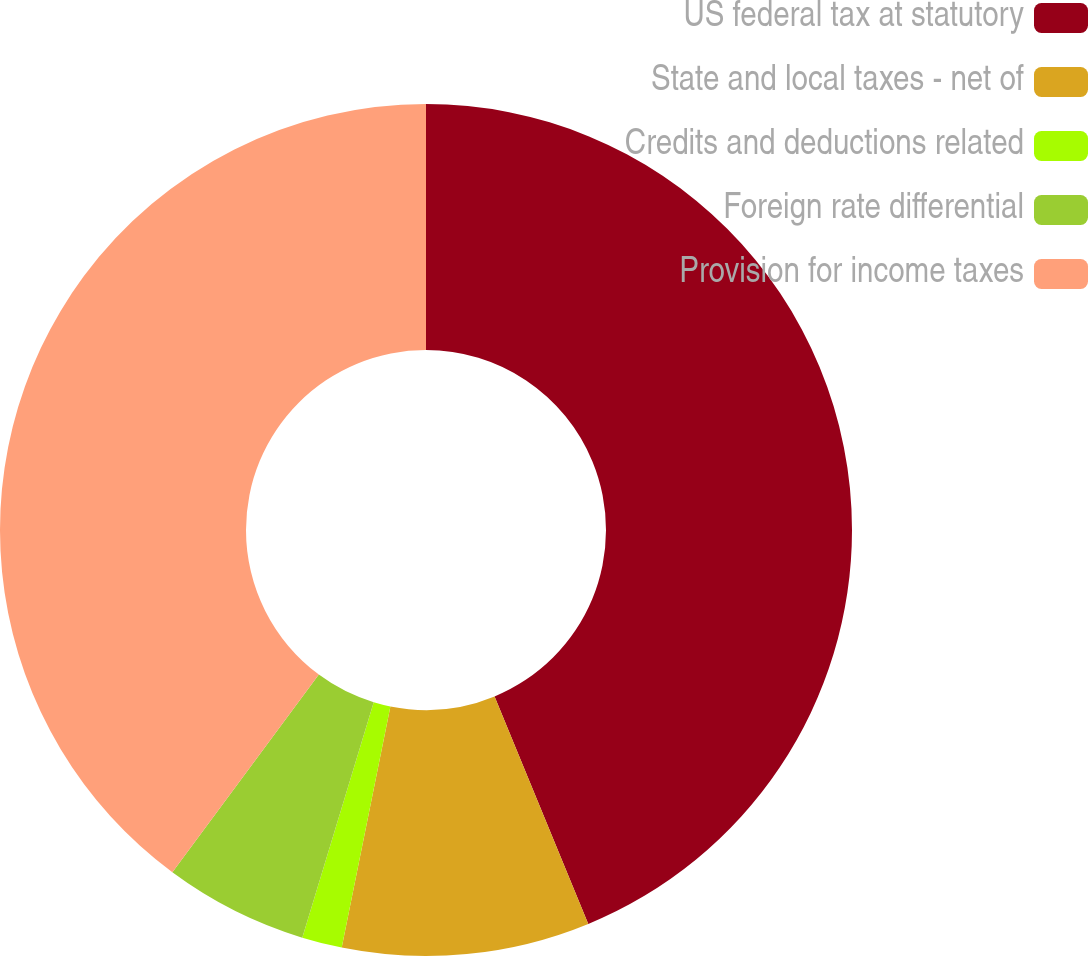Convert chart. <chart><loc_0><loc_0><loc_500><loc_500><pie_chart><fcel>US federal tax at statutory<fcel>State and local taxes - net of<fcel>Credits and deductions related<fcel>Foreign rate differential<fcel>Provision for income taxes<nl><fcel>43.78%<fcel>9.39%<fcel>1.52%<fcel>5.46%<fcel>39.85%<nl></chart> 